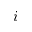<formula> <loc_0><loc_0><loc_500><loc_500>i</formula> 